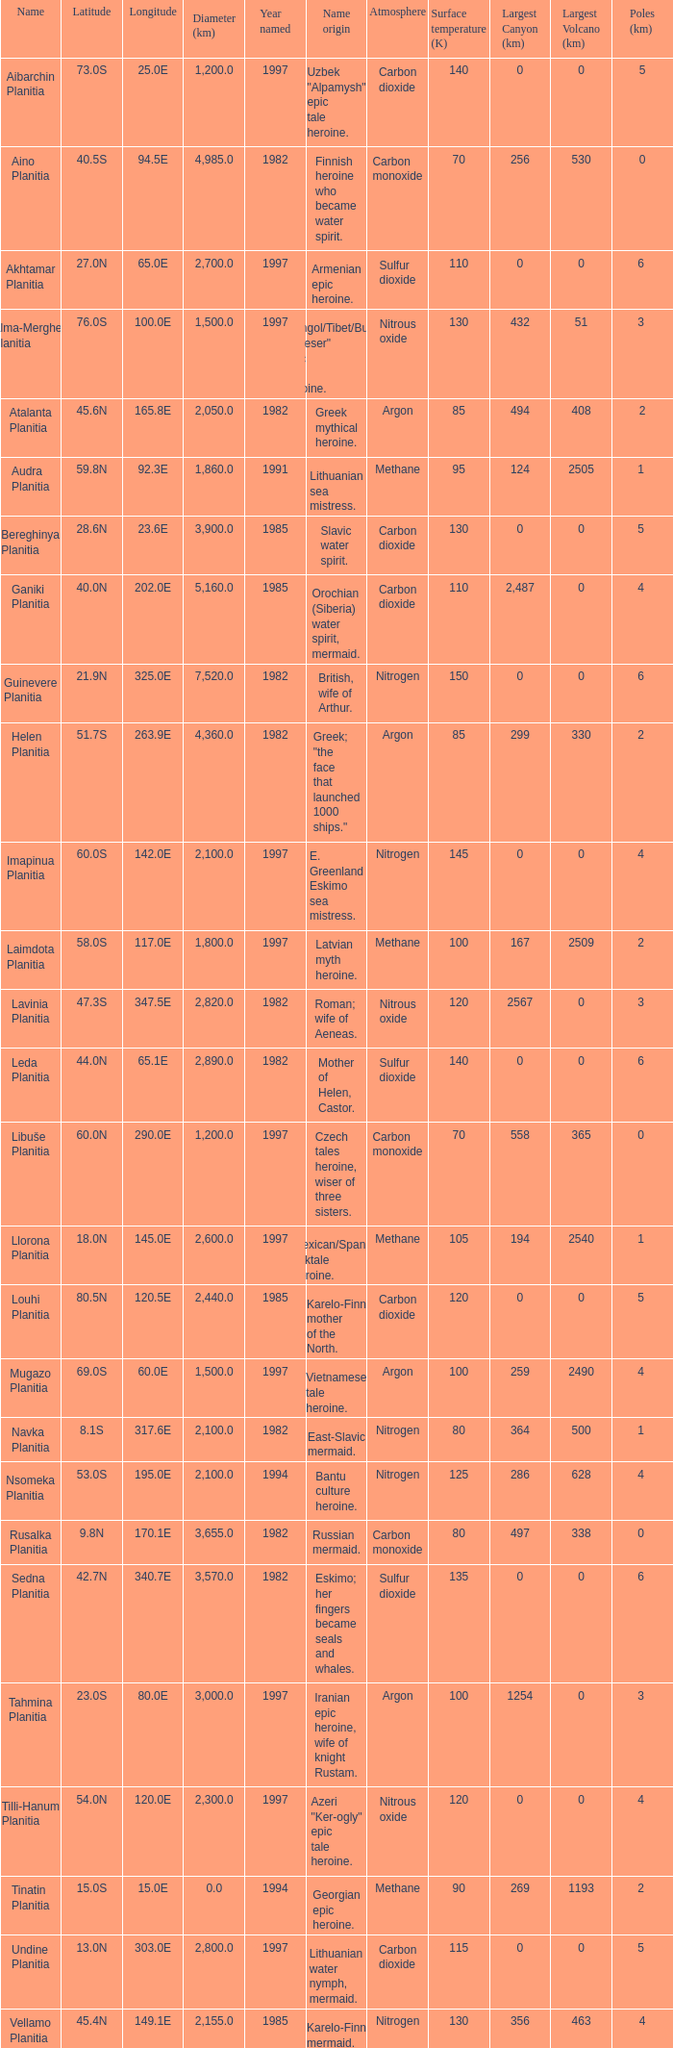What is the diameter (km) of longitude 170.1e 3655.0. 